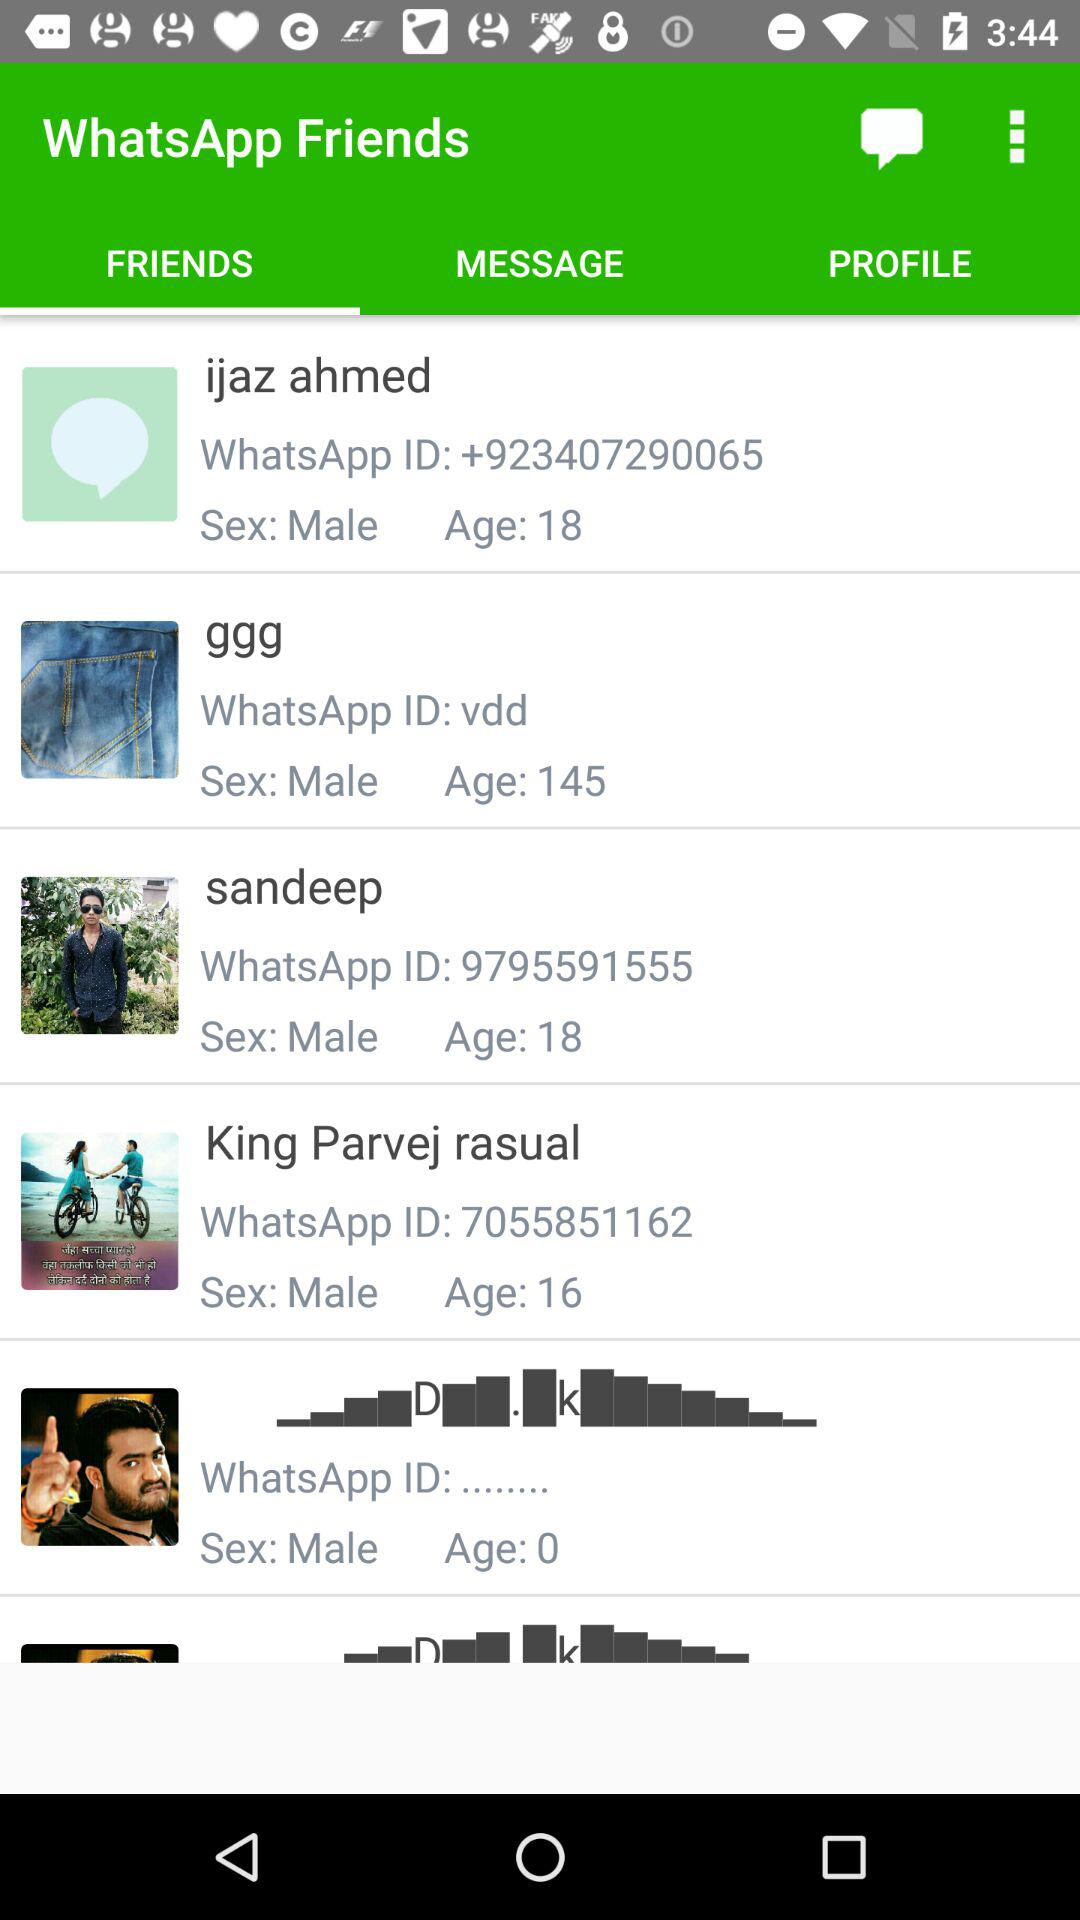What is the WhatsApp ID of "ggg"? The WhatsApp ID is vdd. 